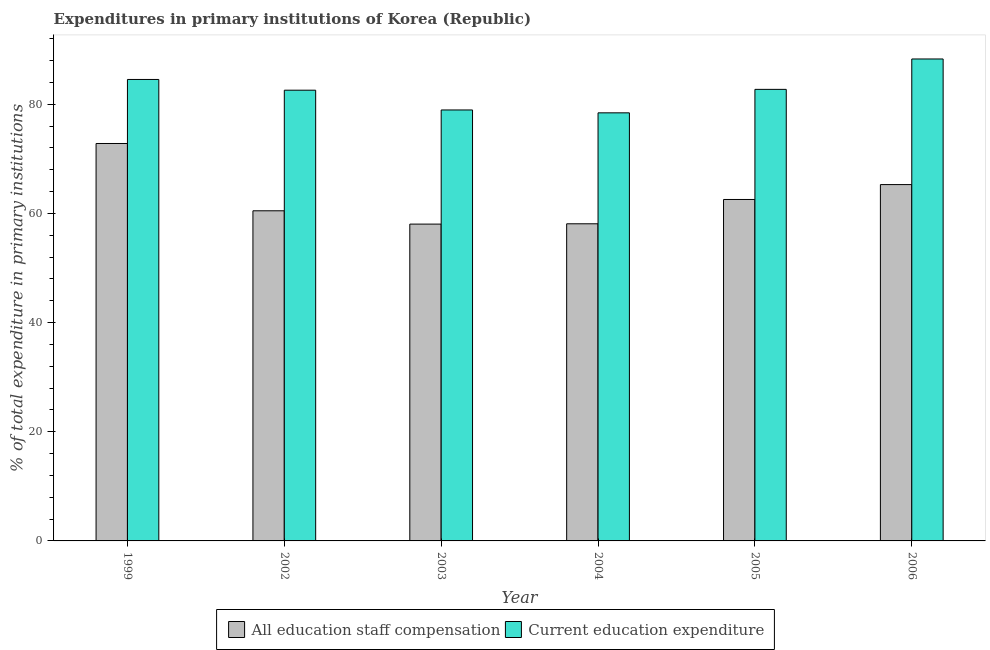How many different coloured bars are there?
Provide a succinct answer. 2. Are the number of bars per tick equal to the number of legend labels?
Offer a terse response. Yes. How many bars are there on the 2nd tick from the left?
Your response must be concise. 2. How many bars are there on the 2nd tick from the right?
Your response must be concise. 2. What is the label of the 4th group of bars from the left?
Ensure brevity in your answer.  2004. What is the expenditure in staff compensation in 2004?
Offer a terse response. 58.11. Across all years, what is the maximum expenditure in staff compensation?
Make the answer very short. 72.82. Across all years, what is the minimum expenditure in education?
Make the answer very short. 78.43. In which year was the expenditure in education maximum?
Ensure brevity in your answer.  2006. In which year was the expenditure in staff compensation minimum?
Offer a very short reply. 2003. What is the total expenditure in education in the graph?
Give a very brief answer. 495.56. What is the difference between the expenditure in education in 2004 and that in 2006?
Keep it short and to the point. -9.87. What is the difference between the expenditure in staff compensation in 2003 and the expenditure in education in 2004?
Offer a very short reply. -0.06. What is the average expenditure in education per year?
Provide a succinct answer. 82.59. In how many years, is the expenditure in staff compensation greater than 52 %?
Provide a succinct answer. 6. What is the ratio of the expenditure in staff compensation in 2005 to that in 2006?
Ensure brevity in your answer.  0.96. Is the difference between the expenditure in staff compensation in 2004 and 2005 greater than the difference between the expenditure in education in 2004 and 2005?
Keep it short and to the point. No. What is the difference between the highest and the second highest expenditure in staff compensation?
Provide a succinct answer. 7.53. What is the difference between the highest and the lowest expenditure in education?
Offer a terse response. 9.87. In how many years, is the expenditure in staff compensation greater than the average expenditure in staff compensation taken over all years?
Your response must be concise. 2. Is the sum of the expenditure in education in 1999 and 2005 greater than the maximum expenditure in staff compensation across all years?
Your answer should be very brief. Yes. What does the 1st bar from the left in 1999 represents?
Provide a short and direct response. All education staff compensation. What does the 1st bar from the right in 2006 represents?
Ensure brevity in your answer.  Current education expenditure. What is the difference between two consecutive major ticks on the Y-axis?
Your response must be concise. 20. Does the graph contain grids?
Offer a terse response. No. Where does the legend appear in the graph?
Offer a terse response. Bottom center. How are the legend labels stacked?
Ensure brevity in your answer.  Horizontal. What is the title of the graph?
Your answer should be very brief. Expenditures in primary institutions of Korea (Republic). What is the label or title of the X-axis?
Your answer should be very brief. Year. What is the label or title of the Y-axis?
Keep it short and to the point. % of total expenditure in primary institutions. What is the % of total expenditure in primary institutions in All education staff compensation in 1999?
Offer a very short reply. 72.82. What is the % of total expenditure in primary institutions of Current education expenditure in 1999?
Offer a terse response. 84.55. What is the % of total expenditure in primary institutions of All education staff compensation in 2002?
Provide a succinct answer. 60.49. What is the % of total expenditure in primary institutions of Current education expenditure in 2002?
Your answer should be very brief. 82.58. What is the % of total expenditure in primary institutions of All education staff compensation in 2003?
Provide a short and direct response. 58.05. What is the % of total expenditure in primary institutions in Current education expenditure in 2003?
Provide a short and direct response. 78.96. What is the % of total expenditure in primary institutions in All education staff compensation in 2004?
Make the answer very short. 58.11. What is the % of total expenditure in primary institutions of Current education expenditure in 2004?
Provide a succinct answer. 78.43. What is the % of total expenditure in primary institutions of All education staff compensation in 2005?
Ensure brevity in your answer.  62.56. What is the % of total expenditure in primary institutions of Current education expenditure in 2005?
Your response must be concise. 82.73. What is the % of total expenditure in primary institutions in All education staff compensation in 2006?
Your answer should be compact. 65.29. What is the % of total expenditure in primary institutions of Current education expenditure in 2006?
Your answer should be very brief. 88.3. Across all years, what is the maximum % of total expenditure in primary institutions of All education staff compensation?
Give a very brief answer. 72.82. Across all years, what is the maximum % of total expenditure in primary institutions in Current education expenditure?
Make the answer very short. 88.3. Across all years, what is the minimum % of total expenditure in primary institutions of All education staff compensation?
Keep it short and to the point. 58.05. Across all years, what is the minimum % of total expenditure in primary institutions of Current education expenditure?
Keep it short and to the point. 78.43. What is the total % of total expenditure in primary institutions of All education staff compensation in the graph?
Provide a succinct answer. 377.31. What is the total % of total expenditure in primary institutions of Current education expenditure in the graph?
Give a very brief answer. 495.56. What is the difference between the % of total expenditure in primary institutions in All education staff compensation in 1999 and that in 2002?
Keep it short and to the point. 12.33. What is the difference between the % of total expenditure in primary institutions of Current education expenditure in 1999 and that in 2002?
Provide a short and direct response. 1.96. What is the difference between the % of total expenditure in primary institutions in All education staff compensation in 1999 and that in 2003?
Your answer should be very brief. 14.77. What is the difference between the % of total expenditure in primary institutions in Current education expenditure in 1999 and that in 2003?
Give a very brief answer. 5.59. What is the difference between the % of total expenditure in primary institutions in All education staff compensation in 1999 and that in 2004?
Your response must be concise. 14.71. What is the difference between the % of total expenditure in primary institutions in Current education expenditure in 1999 and that in 2004?
Your answer should be very brief. 6.11. What is the difference between the % of total expenditure in primary institutions in All education staff compensation in 1999 and that in 2005?
Ensure brevity in your answer.  10.26. What is the difference between the % of total expenditure in primary institutions in Current education expenditure in 1999 and that in 2005?
Provide a succinct answer. 1.81. What is the difference between the % of total expenditure in primary institutions in All education staff compensation in 1999 and that in 2006?
Provide a short and direct response. 7.53. What is the difference between the % of total expenditure in primary institutions in Current education expenditure in 1999 and that in 2006?
Your response must be concise. -3.76. What is the difference between the % of total expenditure in primary institutions in All education staff compensation in 2002 and that in 2003?
Provide a succinct answer. 2.44. What is the difference between the % of total expenditure in primary institutions of Current education expenditure in 2002 and that in 2003?
Make the answer very short. 3.62. What is the difference between the % of total expenditure in primary institutions in All education staff compensation in 2002 and that in 2004?
Your answer should be compact. 2.38. What is the difference between the % of total expenditure in primary institutions in Current education expenditure in 2002 and that in 2004?
Offer a very short reply. 4.15. What is the difference between the % of total expenditure in primary institutions of All education staff compensation in 2002 and that in 2005?
Make the answer very short. -2.07. What is the difference between the % of total expenditure in primary institutions of Current education expenditure in 2002 and that in 2005?
Provide a short and direct response. -0.15. What is the difference between the % of total expenditure in primary institutions of All education staff compensation in 2002 and that in 2006?
Provide a succinct answer. -4.8. What is the difference between the % of total expenditure in primary institutions in Current education expenditure in 2002 and that in 2006?
Ensure brevity in your answer.  -5.72. What is the difference between the % of total expenditure in primary institutions of All education staff compensation in 2003 and that in 2004?
Offer a terse response. -0.06. What is the difference between the % of total expenditure in primary institutions of Current education expenditure in 2003 and that in 2004?
Ensure brevity in your answer.  0.53. What is the difference between the % of total expenditure in primary institutions in All education staff compensation in 2003 and that in 2005?
Keep it short and to the point. -4.51. What is the difference between the % of total expenditure in primary institutions of Current education expenditure in 2003 and that in 2005?
Keep it short and to the point. -3.77. What is the difference between the % of total expenditure in primary institutions of All education staff compensation in 2003 and that in 2006?
Your response must be concise. -7.24. What is the difference between the % of total expenditure in primary institutions of Current education expenditure in 2003 and that in 2006?
Offer a terse response. -9.34. What is the difference between the % of total expenditure in primary institutions of All education staff compensation in 2004 and that in 2005?
Give a very brief answer. -4.45. What is the difference between the % of total expenditure in primary institutions of Current education expenditure in 2004 and that in 2005?
Offer a very short reply. -4.3. What is the difference between the % of total expenditure in primary institutions of All education staff compensation in 2004 and that in 2006?
Make the answer very short. -7.18. What is the difference between the % of total expenditure in primary institutions in Current education expenditure in 2004 and that in 2006?
Make the answer very short. -9.87. What is the difference between the % of total expenditure in primary institutions of All education staff compensation in 2005 and that in 2006?
Your answer should be compact. -2.73. What is the difference between the % of total expenditure in primary institutions of Current education expenditure in 2005 and that in 2006?
Make the answer very short. -5.57. What is the difference between the % of total expenditure in primary institutions in All education staff compensation in 1999 and the % of total expenditure in primary institutions in Current education expenditure in 2002?
Your response must be concise. -9.77. What is the difference between the % of total expenditure in primary institutions of All education staff compensation in 1999 and the % of total expenditure in primary institutions of Current education expenditure in 2003?
Your answer should be very brief. -6.15. What is the difference between the % of total expenditure in primary institutions in All education staff compensation in 1999 and the % of total expenditure in primary institutions in Current education expenditure in 2004?
Your answer should be very brief. -5.62. What is the difference between the % of total expenditure in primary institutions in All education staff compensation in 1999 and the % of total expenditure in primary institutions in Current education expenditure in 2005?
Keep it short and to the point. -9.92. What is the difference between the % of total expenditure in primary institutions of All education staff compensation in 1999 and the % of total expenditure in primary institutions of Current education expenditure in 2006?
Keep it short and to the point. -15.49. What is the difference between the % of total expenditure in primary institutions of All education staff compensation in 2002 and the % of total expenditure in primary institutions of Current education expenditure in 2003?
Your response must be concise. -18.48. What is the difference between the % of total expenditure in primary institutions in All education staff compensation in 2002 and the % of total expenditure in primary institutions in Current education expenditure in 2004?
Provide a short and direct response. -17.95. What is the difference between the % of total expenditure in primary institutions of All education staff compensation in 2002 and the % of total expenditure in primary institutions of Current education expenditure in 2005?
Your answer should be compact. -22.25. What is the difference between the % of total expenditure in primary institutions in All education staff compensation in 2002 and the % of total expenditure in primary institutions in Current education expenditure in 2006?
Ensure brevity in your answer.  -27.82. What is the difference between the % of total expenditure in primary institutions of All education staff compensation in 2003 and the % of total expenditure in primary institutions of Current education expenditure in 2004?
Keep it short and to the point. -20.39. What is the difference between the % of total expenditure in primary institutions in All education staff compensation in 2003 and the % of total expenditure in primary institutions in Current education expenditure in 2005?
Give a very brief answer. -24.69. What is the difference between the % of total expenditure in primary institutions of All education staff compensation in 2003 and the % of total expenditure in primary institutions of Current education expenditure in 2006?
Provide a succinct answer. -30.25. What is the difference between the % of total expenditure in primary institutions in All education staff compensation in 2004 and the % of total expenditure in primary institutions in Current education expenditure in 2005?
Offer a terse response. -24.63. What is the difference between the % of total expenditure in primary institutions of All education staff compensation in 2004 and the % of total expenditure in primary institutions of Current education expenditure in 2006?
Keep it short and to the point. -30.2. What is the difference between the % of total expenditure in primary institutions of All education staff compensation in 2005 and the % of total expenditure in primary institutions of Current education expenditure in 2006?
Provide a short and direct response. -25.74. What is the average % of total expenditure in primary institutions in All education staff compensation per year?
Provide a short and direct response. 62.88. What is the average % of total expenditure in primary institutions in Current education expenditure per year?
Offer a terse response. 82.59. In the year 1999, what is the difference between the % of total expenditure in primary institutions of All education staff compensation and % of total expenditure in primary institutions of Current education expenditure?
Your answer should be compact. -11.73. In the year 2002, what is the difference between the % of total expenditure in primary institutions of All education staff compensation and % of total expenditure in primary institutions of Current education expenditure?
Your response must be concise. -22.1. In the year 2003, what is the difference between the % of total expenditure in primary institutions in All education staff compensation and % of total expenditure in primary institutions in Current education expenditure?
Your response must be concise. -20.91. In the year 2004, what is the difference between the % of total expenditure in primary institutions in All education staff compensation and % of total expenditure in primary institutions in Current education expenditure?
Make the answer very short. -20.33. In the year 2005, what is the difference between the % of total expenditure in primary institutions of All education staff compensation and % of total expenditure in primary institutions of Current education expenditure?
Offer a terse response. -20.18. In the year 2006, what is the difference between the % of total expenditure in primary institutions in All education staff compensation and % of total expenditure in primary institutions in Current education expenditure?
Your response must be concise. -23.01. What is the ratio of the % of total expenditure in primary institutions of All education staff compensation in 1999 to that in 2002?
Provide a short and direct response. 1.2. What is the ratio of the % of total expenditure in primary institutions in Current education expenditure in 1999 to that in 2002?
Provide a succinct answer. 1.02. What is the ratio of the % of total expenditure in primary institutions of All education staff compensation in 1999 to that in 2003?
Offer a very short reply. 1.25. What is the ratio of the % of total expenditure in primary institutions in Current education expenditure in 1999 to that in 2003?
Give a very brief answer. 1.07. What is the ratio of the % of total expenditure in primary institutions of All education staff compensation in 1999 to that in 2004?
Offer a very short reply. 1.25. What is the ratio of the % of total expenditure in primary institutions in Current education expenditure in 1999 to that in 2004?
Make the answer very short. 1.08. What is the ratio of the % of total expenditure in primary institutions in All education staff compensation in 1999 to that in 2005?
Keep it short and to the point. 1.16. What is the ratio of the % of total expenditure in primary institutions of Current education expenditure in 1999 to that in 2005?
Your answer should be compact. 1.02. What is the ratio of the % of total expenditure in primary institutions in All education staff compensation in 1999 to that in 2006?
Your response must be concise. 1.12. What is the ratio of the % of total expenditure in primary institutions in Current education expenditure in 1999 to that in 2006?
Give a very brief answer. 0.96. What is the ratio of the % of total expenditure in primary institutions of All education staff compensation in 2002 to that in 2003?
Ensure brevity in your answer.  1.04. What is the ratio of the % of total expenditure in primary institutions of Current education expenditure in 2002 to that in 2003?
Offer a very short reply. 1.05. What is the ratio of the % of total expenditure in primary institutions in All education staff compensation in 2002 to that in 2004?
Make the answer very short. 1.04. What is the ratio of the % of total expenditure in primary institutions in Current education expenditure in 2002 to that in 2004?
Your answer should be very brief. 1.05. What is the ratio of the % of total expenditure in primary institutions in All education staff compensation in 2002 to that in 2005?
Keep it short and to the point. 0.97. What is the ratio of the % of total expenditure in primary institutions in Current education expenditure in 2002 to that in 2005?
Offer a terse response. 1. What is the ratio of the % of total expenditure in primary institutions of All education staff compensation in 2002 to that in 2006?
Offer a terse response. 0.93. What is the ratio of the % of total expenditure in primary institutions of Current education expenditure in 2002 to that in 2006?
Give a very brief answer. 0.94. What is the ratio of the % of total expenditure in primary institutions in All education staff compensation in 2003 to that in 2005?
Offer a terse response. 0.93. What is the ratio of the % of total expenditure in primary institutions of Current education expenditure in 2003 to that in 2005?
Provide a short and direct response. 0.95. What is the ratio of the % of total expenditure in primary institutions in All education staff compensation in 2003 to that in 2006?
Make the answer very short. 0.89. What is the ratio of the % of total expenditure in primary institutions of Current education expenditure in 2003 to that in 2006?
Keep it short and to the point. 0.89. What is the ratio of the % of total expenditure in primary institutions of All education staff compensation in 2004 to that in 2005?
Ensure brevity in your answer.  0.93. What is the ratio of the % of total expenditure in primary institutions in Current education expenditure in 2004 to that in 2005?
Your response must be concise. 0.95. What is the ratio of the % of total expenditure in primary institutions in All education staff compensation in 2004 to that in 2006?
Offer a very short reply. 0.89. What is the ratio of the % of total expenditure in primary institutions in Current education expenditure in 2004 to that in 2006?
Ensure brevity in your answer.  0.89. What is the ratio of the % of total expenditure in primary institutions in All education staff compensation in 2005 to that in 2006?
Offer a very short reply. 0.96. What is the ratio of the % of total expenditure in primary institutions of Current education expenditure in 2005 to that in 2006?
Keep it short and to the point. 0.94. What is the difference between the highest and the second highest % of total expenditure in primary institutions of All education staff compensation?
Ensure brevity in your answer.  7.53. What is the difference between the highest and the second highest % of total expenditure in primary institutions of Current education expenditure?
Provide a succinct answer. 3.76. What is the difference between the highest and the lowest % of total expenditure in primary institutions in All education staff compensation?
Make the answer very short. 14.77. What is the difference between the highest and the lowest % of total expenditure in primary institutions in Current education expenditure?
Your answer should be very brief. 9.87. 